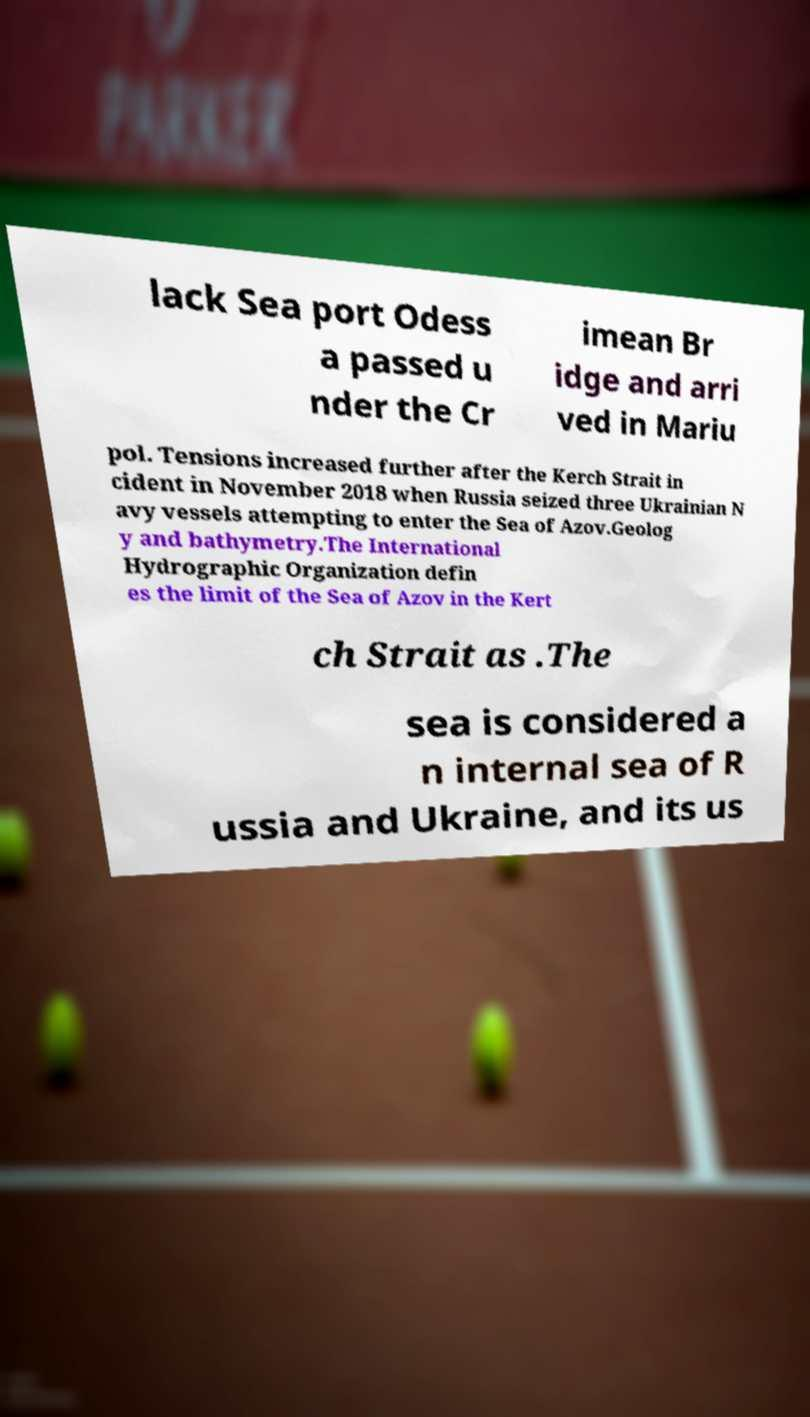For documentation purposes, I need the text within this image transcribed. Could you provide that? lack Sea port Odess a passed u nder the Cr imean Br idge and arri ved in Mariu pol. Tensions increased further after the Kerch Strait in cident in November 2018 when Russia seized three Ukrainian N avy vessels attempting to enter the Sea of Azov.Geolog y and bathymetry.The International Hydrographic Organization defin es the limit of the Sea of Azov in the Kert ch Strait as .The sea is considered a n internal sea of R ussia and Ukraine, and its us 